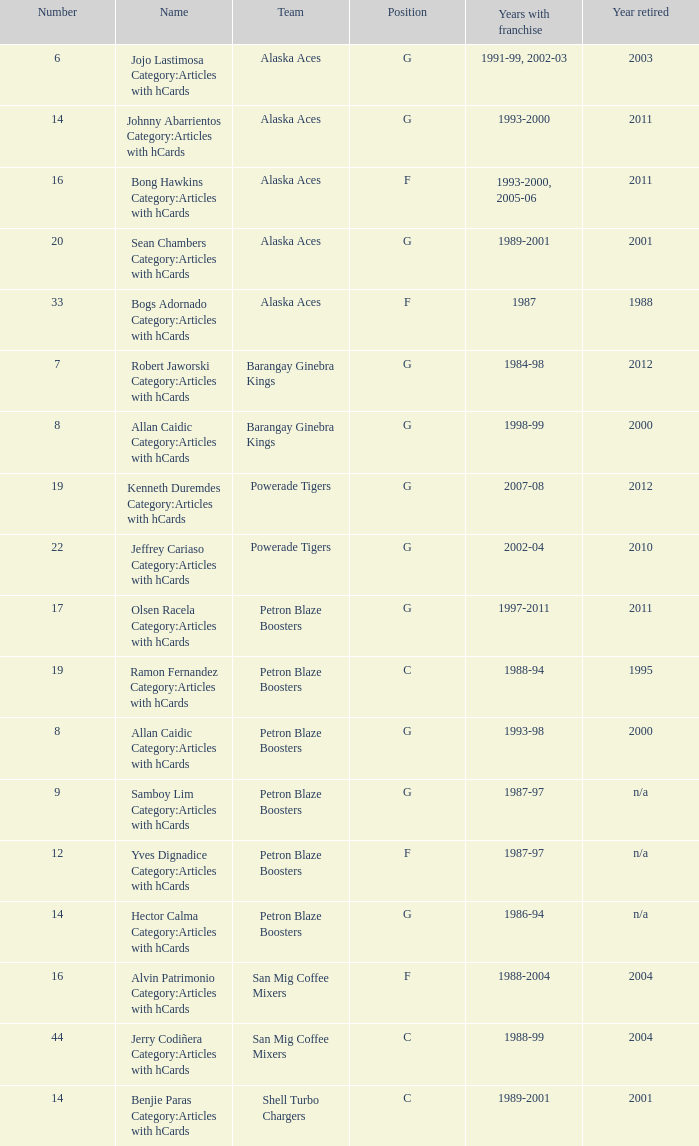For how many years has the team in the 9th position had a franchise? 1987-97. 